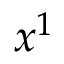Convert formula to latex. <formula><loc_0><loc_0><loc_500><loc_500>x ^ { 1 }</formula> 